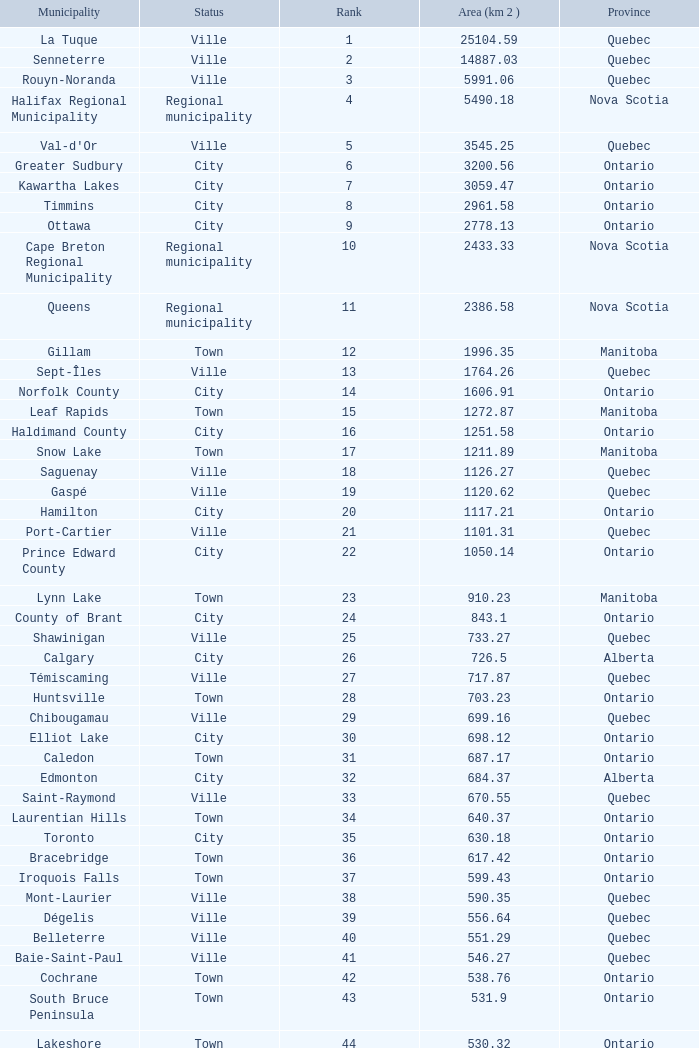What is the total Rank that has a Municipality of Winnipeg, an Area (KM 2) that's larger than 464.01? None. 